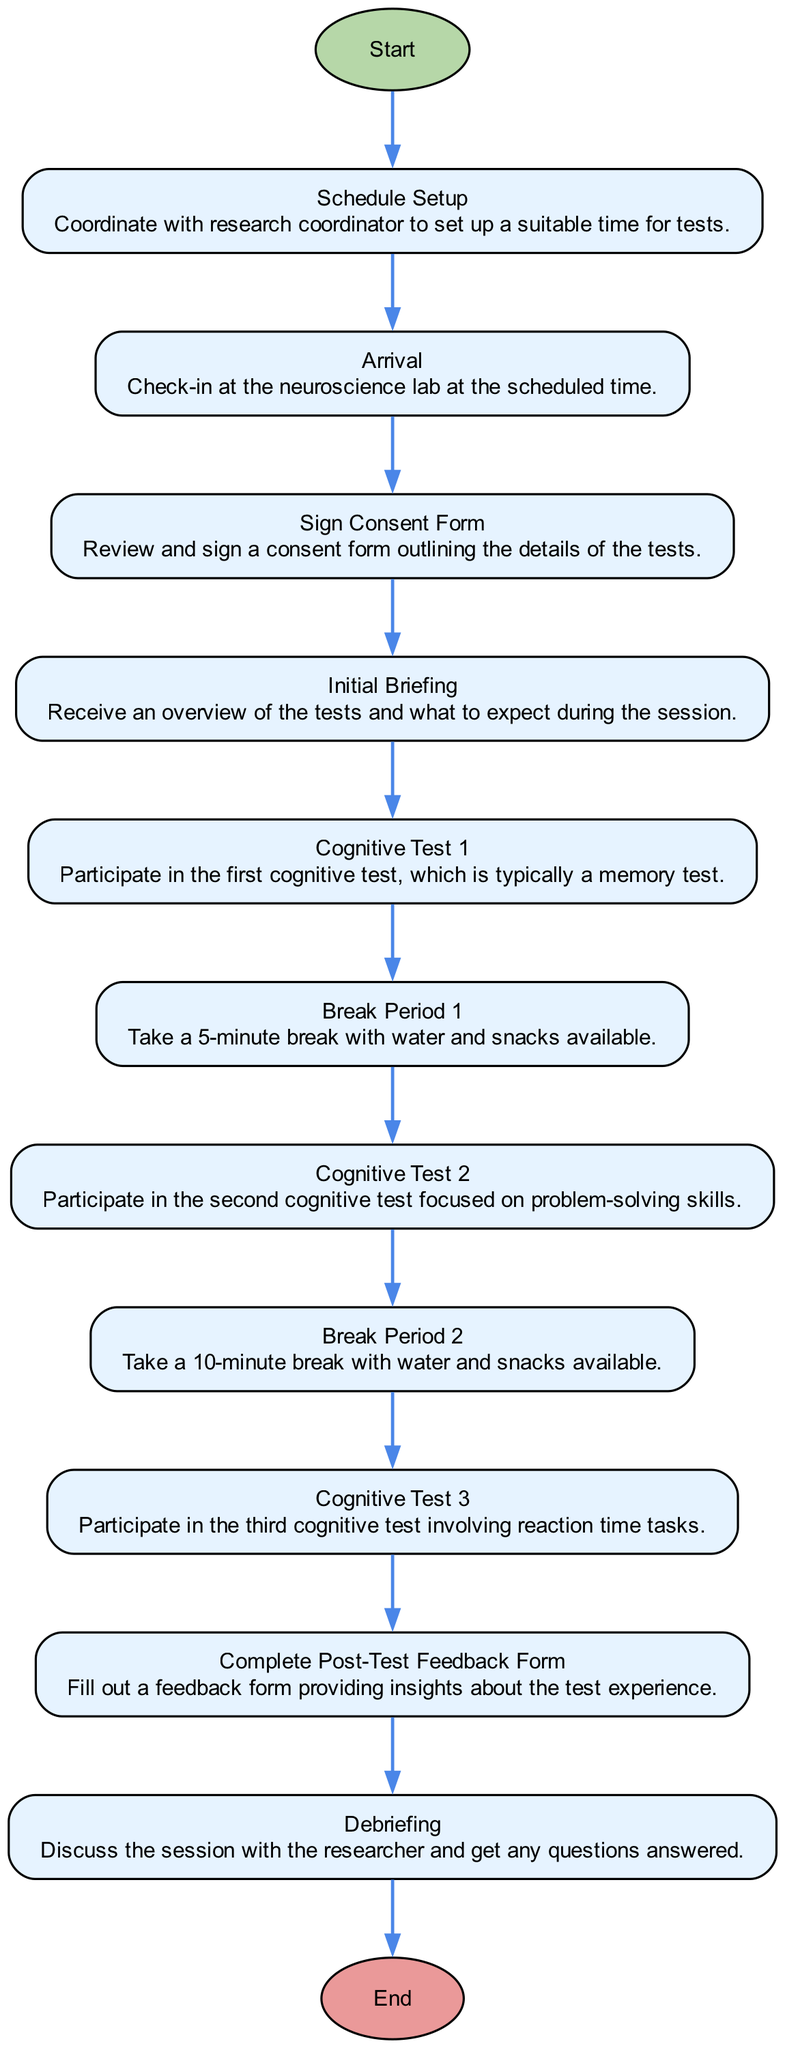What is the first step in the workflow? The first step in the workflow is labeled "Start," indicating the beginning of the process.
Answer: Start How many cognitive tests are included in the workflow? The workflow includes three cognitive tests, each labeled as "Cognitive Test 1," "Cognitive Test 2," and "Cognitive Test 3."
Answer: 3 What follows after the "Initial Briefing"? After the "Initial Briefing," the next step is "Cognitive Test 1," which signifies the start of the testing phase following the briefing.
Answer: Cognitive Test 1 What is the duration of "Break Period 1"? The duration of "Break Period 1" is specified as 5 minutes, which is indicated in the description of that step.
Answer: 5 minutes How does the workflow handle breaks? The workflow includes two break periods, one lasting 5 minutes after the first test and another lasting 10 minutes after the second test, facilitating recovery between tests.
Answer: Two breaks What is the purpose of the "Post-Test Feedback Form"? The "Post-Test Feedback Form" is designed for participants to fill out after completing the tests, allowing them to provide insights and feedback on their experience.
Answer: Feedback What occurs just before the "Debriefing" step? Before the "Debriefing" step, participants must complete the "Post-Test Feedback Form," indicating that feedback collection occurs prior to the final discussion with the researcher.
Answer: Complete Post-Test Feedback Form Which step involves drinking water and having snacks? "Break Period 1" and "Break Period 2" both include provisions for water and snacks, making them the steps that facilitate refreshments.
Answer: Break Period 1 and Break Period 2 What is the last step in the workflow? The last step in the workflow is labeled "End," signaling the conclusion of the testing and feedback process for the participant.
Answer: End 